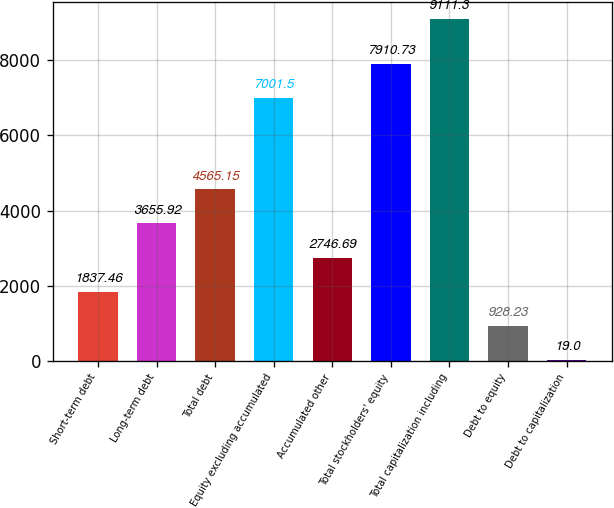Convert chart. <chart><loc_0><loc_0><loc_500><loc_500><bar_chart><fcel>Short-term debt<fcel>Long-term debt<fcel>Total debt<fcel>Equity excluding accumulated<fcel>Accumulated other<fcel>Total stockholders' equity<fcel>Total capitalization including<fcel>Debt to equity<fcel>Debt to capitalization<nl><fcel>1837.46<fcel>3655.92<fcel>4565.15<fcel>7001.5<fcel>2746.69<fcel>7910.73<fcel>9111.3<fcel>928.23<fcel>19<nl></chart> 